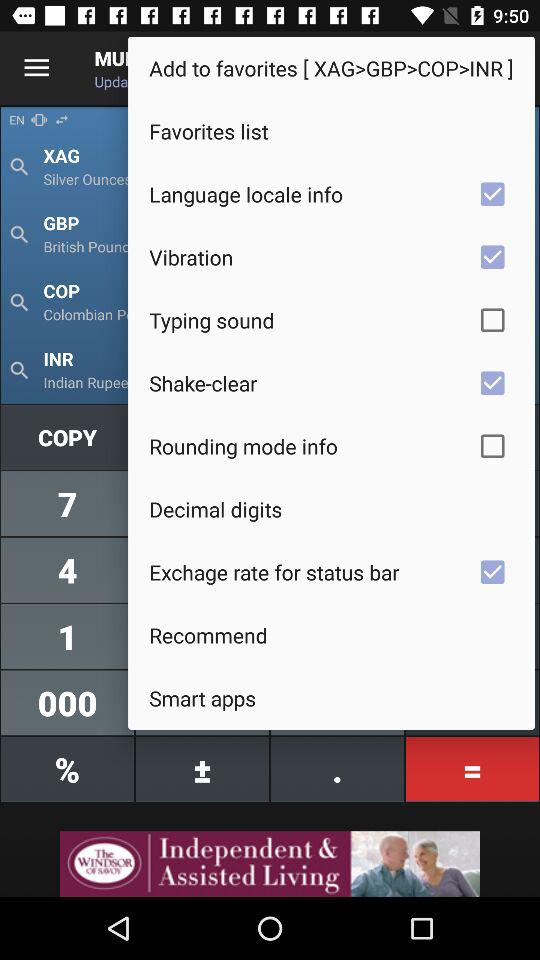What is the status of "Language locale info"? The status is "on". 